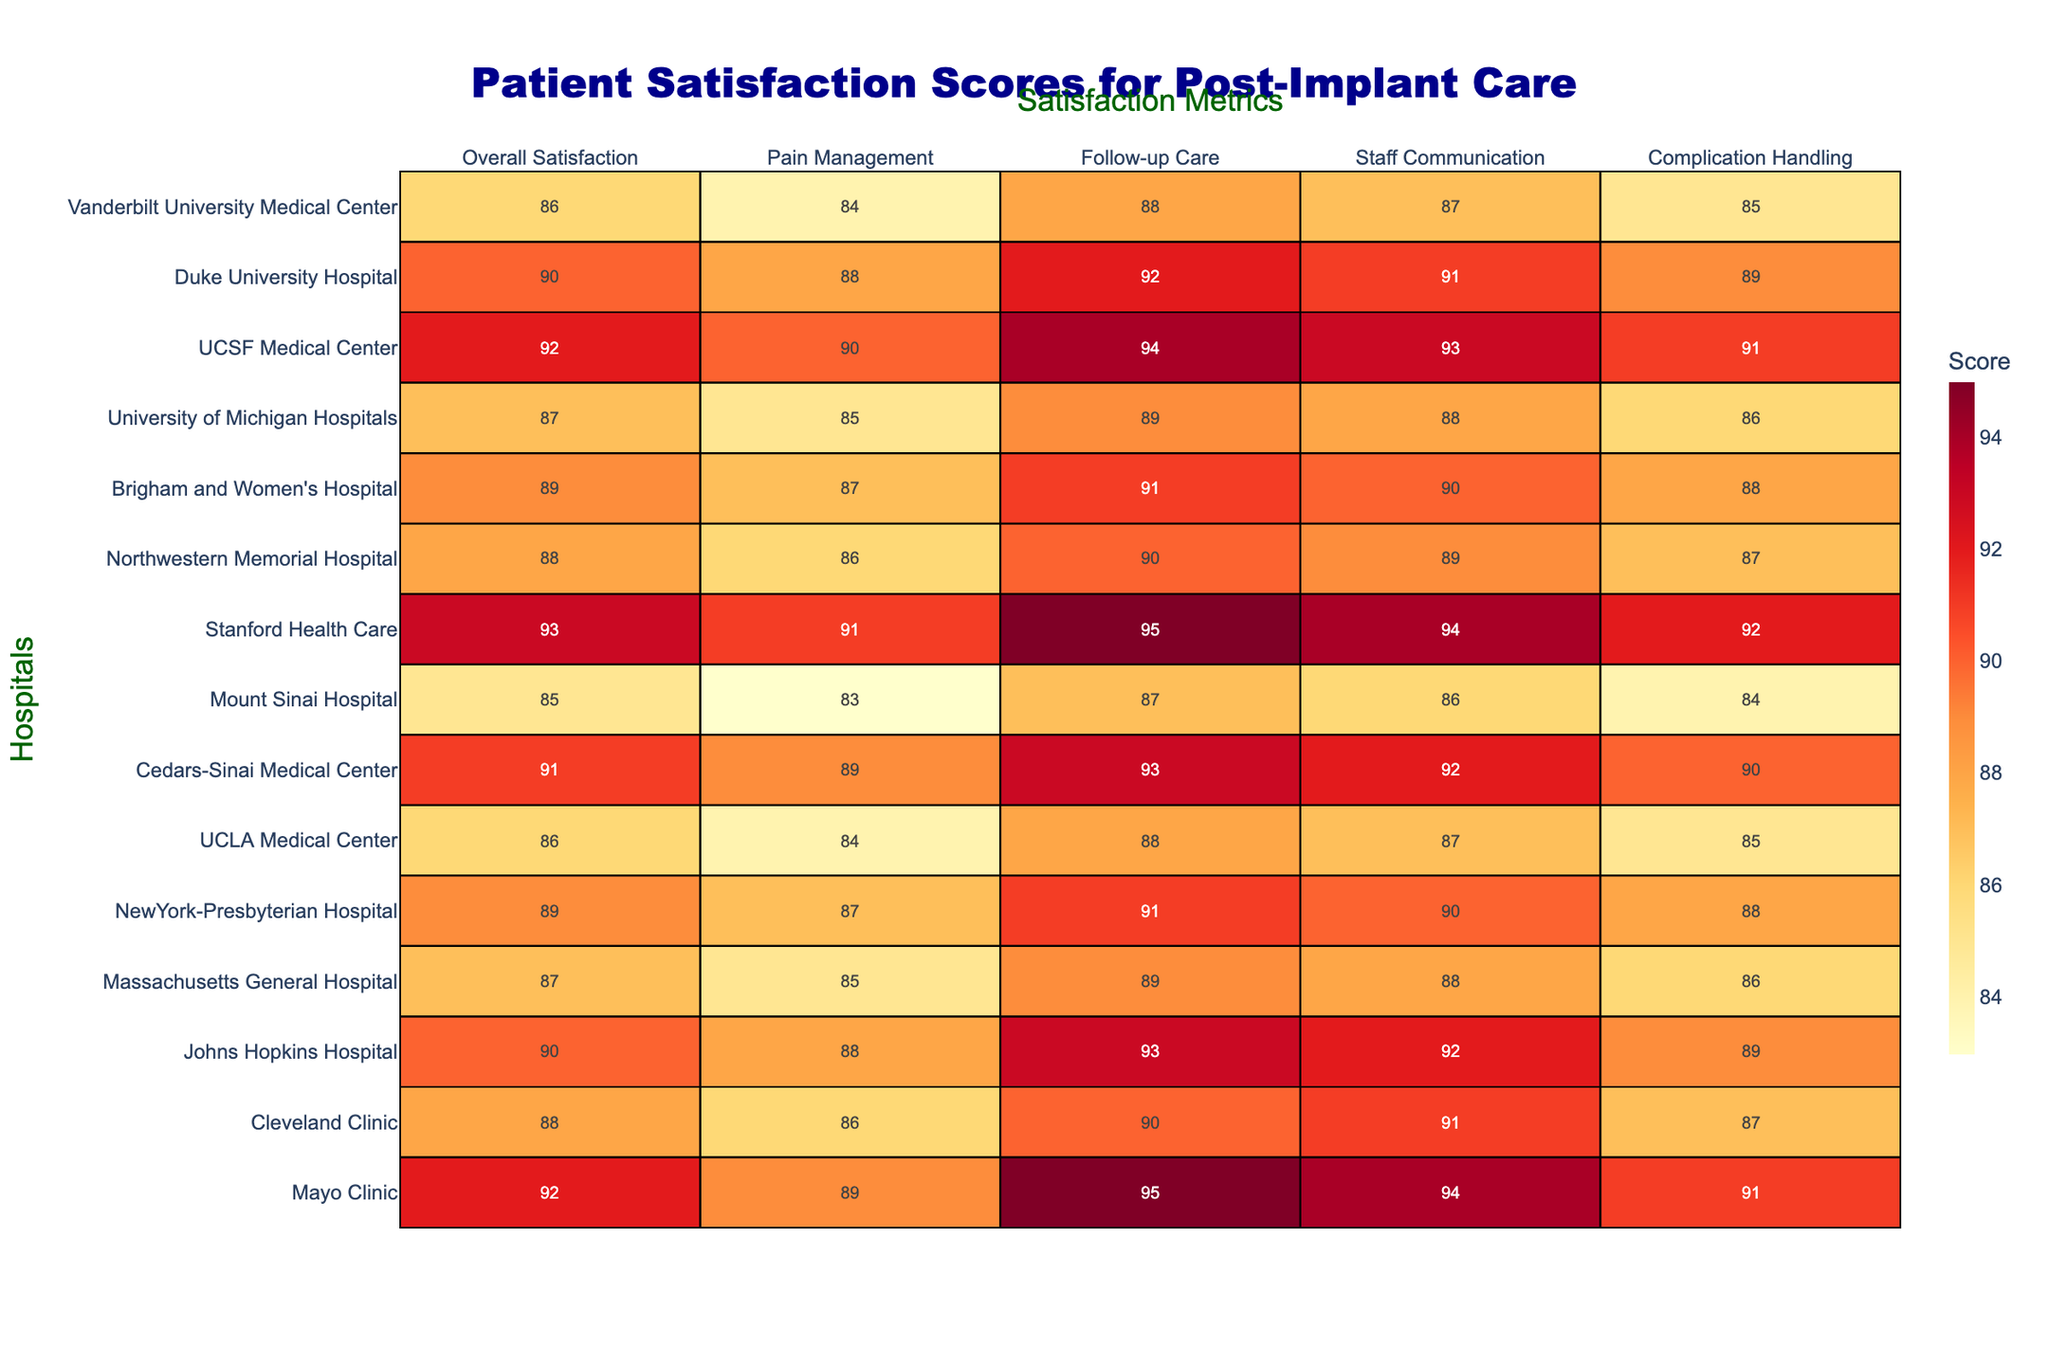What is the overall satisfaction score for Mayo Clinic? The table shows that Mayo Clinic has an overall satisfaction score of 92.
Answer: 92 Which hospital has the highest score in pain management? Looking at the pain management column, Stanford Health Care has the highest score of 91.
Answer: 91 What is the average follow-up care score for the hospitals listed? To find the average follow-up care score, add all the scores (95 + 90 + 93 + 89 + 91 + 88 + 93 + 87 + 95 + 90 + 91 + 89 + 94 + 92 + 88) = 1350, then divide by 15 (the number of hospitals), which equals 90.
Answer: 90 Is the score for complication handling at Johns Hopkins Hospital higher than that at Cleveland Clinic? Johns Hopkins Hospital has a complication handling score of 89, while Cleveland Clinic has a score of 87. Since 89 is greater than 87, the statement is true.
Answer: Yes Which hospital shows the most consistent scores across all metrics? By comparing the scores, Cedars-Sinai Medical Center has scores of 91, 89, 93, 92, and 90, suggesting they are relatively close together. Other hospitals have more variation in their scores.
Answer: Cedars-Sinai Medical Center What is the difference in overall satisfaction scores between UCLA Medical Center and Massachusetts General Hospital? UCLA Medical Center has an overall satisfaction score of 86, and Massachusetts General Hospital has a score of 87. The difference is 87 - 86, which equals 1.
Answer: 1 Which hospital has the lowest score in staff communication? By examining the staff communication column, Mount Sinai Hospital has the lowest score of 86.
Answer: 86 What percentage of hospitals have an overall satisfaction score of 90 or above? There are 6 hospitals with an overall satisfaction score of 90 or above (Mayo Clinic, Johns Hopkins Hospital, Stanford Health Care, UCSF Medical Center, Duke University Hospital, Cedars-Sinai Medical Center) out of 15 hospitals, which is 6/15 = 0.4 or 40%.
Answer: 40% Which hospital has the second highest score in follow-up care? The second highest score in follow-up care is 93, which is achieved by both Johns Hopkins Hospital and UCSF Medical Center.
Answer: Johns Hopkins Hospital and UCSF Medical Center Is it true that all hospitals have a pain management score above 80? By checking the pain management scores, Mount Sinai Hospital and UCLA Medical Center both score 83 and 84, which are above 80. Therefore, the statement is true.
Answer: Yes Which hospital ranks highest in complication handling, and what is the score? The highest complication handling score is 92, which belongs to both Stanford Health Care and Cedars-Sinai Medical Center.
Answer: Stanford Health Care and Cedars-Sinai Medical Center, score 92 